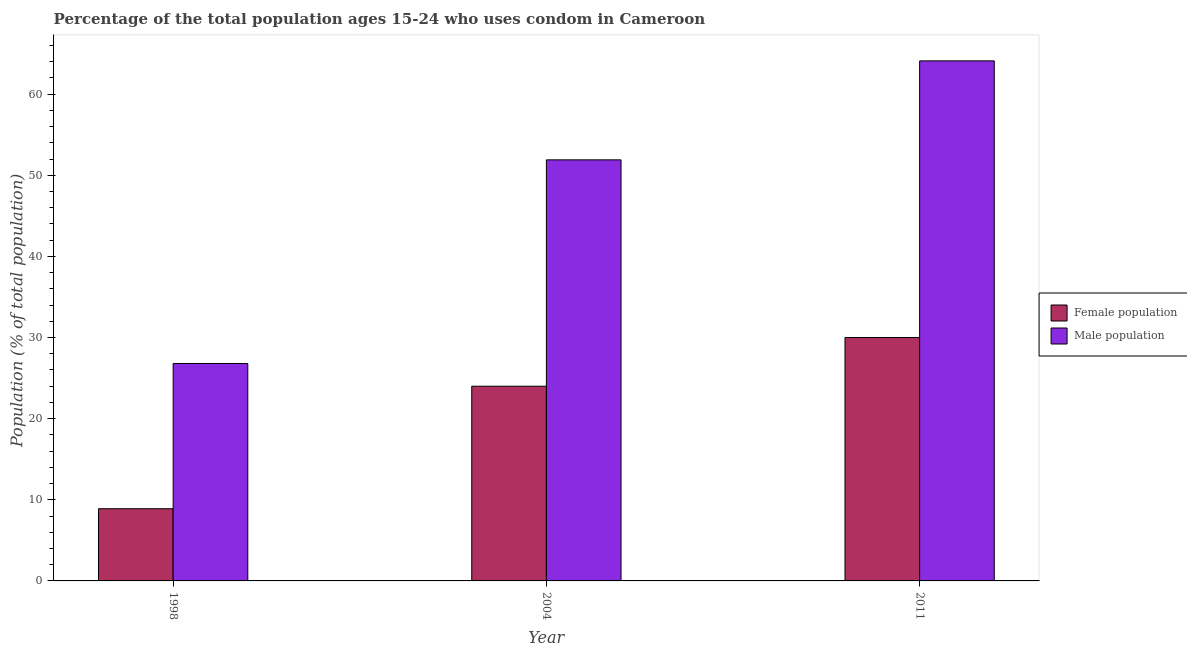Are the number of bars per tick equal to the number of legend labels?
Keep it short and to the point. Yes. Are the number of bars on each tick of the X-axis equal?
Your answer should be compact. Yes. How many bars are there on the 1st tick from the left?
Offer a very short reply. 2. How many bars are there on the 3rd tick from the right?
Keep it short and to the point. 2. In how many cases, is the number of bars for a given year not equal to the number of legend labels?
Your answer should be compact. 0. What is the female population in 2011?
Keep it short and to the point. 30. Across all years, what is the maximum male population?
Provide a short and direct response. 64.1. Across all years, what is the minimum male population?
Keep it short and to the point. 26.8. In which year was the male population maximum?
Your answer should be compact. 2011. In which year was the male population minimum?
Provide a short and direct response. 1998. What is the total male population in the graph?
Your answer should be very brief. 142.8. What is the difference between the male population in 1998 and that in 2011?
Give a very brief answer. -37.3. What is the difference between the female population in 2011 and the male population in 2004?
Your answer should be very brief. 6. What is the average female population per year?
Offer a very short reply. 20.97. In how many years, is the female population greater than 58 %?
Offer a terse response. 0. What is the ratio of the male population in 1998 to that in 2011?
Offer a very short reply. 0.42. Is the difference between the male population in 1998 and 2004 greater than the difference between the female population in 1998 and 2004?
Ensure brevity in your answer.  No. What is the difference between the highest and the second highest male population?
Provide a succinct answer. 12.2. What is the difference between the highest and the lowest male population?
Your response must be concise. 37.3. In how many years, is the male population greater than the average male population taken over all years?
Your answer should be compact. 2. Is the sum of the male population in 1998 and 2004 greater than the maximum female population across all years?
Offer a very short reply. Yes. What does the 2nd bar from the left in 2011 represents?
Your answer should be compact. Male population. What does the 1st bar from the right in 2004 represents?
Provide a short and direct response. Male population. How many bars are there?
Your response must be concise. 6. Are all the bars in the graph horizontal?
Provide a succinct answer. No. How many years are there in the graph?
Provide a succinct answer. 3. Where does the legend appear in the graph?
Offer a terse response. Center right. What is the title of the graph?
Keep it short and to the point. Percentage of the total population ages 15-24 who uses condom in Cameroon. Does "Formally registered" appear as one of the legend labels in the graph?
Your answer should be compact. No. What is the label or title of the Y-axis?
Offer a terse response. Population (% of total population) . What is the Population (% of total population)  of Male population in 1998?
Provide a short and direct response. 26.8. What is the Population (% of total population)  in Female population in 2004?
Offer a very short reply. 24. What is the Population (% of total population)  of Male population in 2004?
Ensure brevity in your answer.  51.9. What is the Population (% of total population)  of Female population in 2011?
Ensure brevity in your answer.  30. What is the Population (% of total population)  in Male population in 2011?
Give a very brief answer. 64.1. Across all years, what is the maximum Population (% of total population)  in Male population?
Give a very brief answer. 64.1. Across all years, what is the minimum Population (% of total population)  in Male population?
Keep it short and to the point. 26.8. What is the total Population (% of total population)  of Female population in the graph?
Give a very brief answer. 62.9. What is the total Population (% of total population)  in Male population in the graph?
Keep it short and to the point. 142.8. What is the difference between the Population (% of total population)  in Female population in 1998 and that in 2004?
Make the answer very short. -15.1. What is the difference between the Population (% of total population)  in Male population in 1998 and that in 2004?
Offer a very short reply. -25.1. What is the difference between the Population (% of total population)  in Female population in 1998 and that in 2011?
Offer a very short reply. -21.1. What is the difference between the Population (% of total population)  of Male population in 1998 and that in 2011?
Your answer should be very brief. -37.3. What is the difference between the Population (% of total population)  in Male population in 2004 and that in 2011?
Offer a terse response. -12.2. What is the difference between the Population (% of total population)  in Female population in 1998 and the Population (% of total population)  in Male population in 2004?
Make the answer very short. -43. What is the difference between the Population (% of total population)  in Female population in 1998 and the Population (% of total population)  in Male population in 2011?
Give a very brief answer. -55.2. What is the difference between the Population (% of total population)  in Female population in 2004 and the Population (% of total population)  in Male population in 2011?
Offer a very short reply. -40.1. What is the average Population (% of total population)  in Female population per year?
Ensure brevity in your answer.  20.97. What is the average Population (% of total population)  in Male population per year?
Offer a terse response. 47.6. In the year 1998, what is the difference between the Population (% of total population)  of Female population and Population (% of total population)  of Male population?
Offer a terse response. -17.9. In the year 2004, what is the difference between the Population (% of total population)  of Female population and Population (% of total population)  of Male population?
Provide a short and direct response. -27.9. In the year 2011, what is the difference between the Population (% of total population)  of Female population and Population (% of total population)  of Male population?
Your answer should be very brief. -34.1. What is the ratio of the Population (% of total population)  in Female population in 1998 to that in 2004?
Your answer should be very brief. 0.37. What is the ratio of the Population (% of total population)  of Male population in 1998 to that in 2004?
Offer a terse response. 0.52. What is the ratio of the Population (% of total population)  of Female population in 1998 to that in 2011?
Offer a terse response. 0.3. What is the ratio of the Population (% of total population)  in Male population in 1998 to that in 2011?
Your answer should be compact. 0.42. What is the ratio of the Population (% of total population)  in Male population in 2004 to that in 2011?
Ensure brevity in your answer.  0.81. What is the difference between the highest and the second highest Population (% of total population)  of Female population?
Your answer should be compact. 6. What is the difference between the highest and the lowest Population (% of total population)  in Female population?
Provide a succinct answer. 21.1. What is the difference between the highest and the lowest Population (% of total population)  in Male population?
Give a very brief answer. 37.3. 